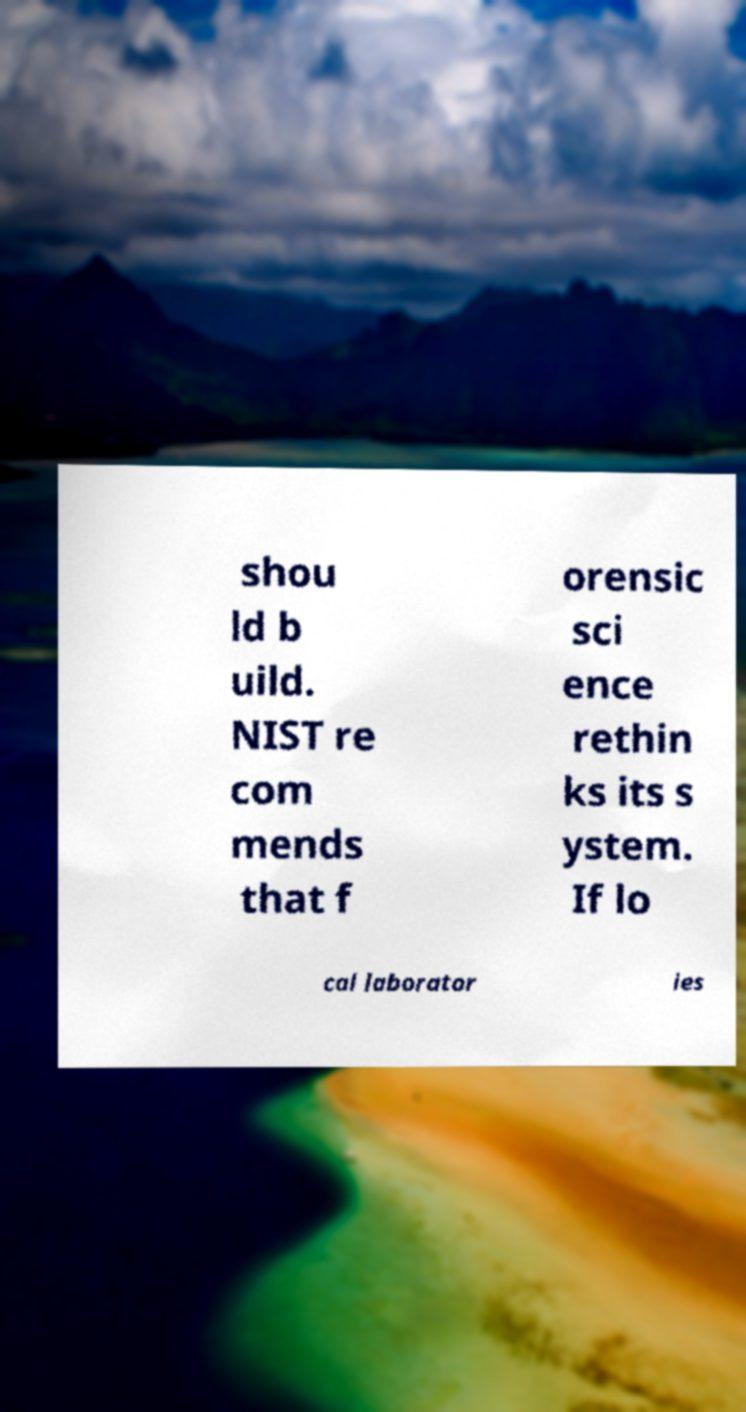Could you assist in decoding the text presented in this image and type it out clearly? shou ld b uild. NIST re com mends that f orensic sci ence rethin ks its s ystem. If lo cal laborator ies 